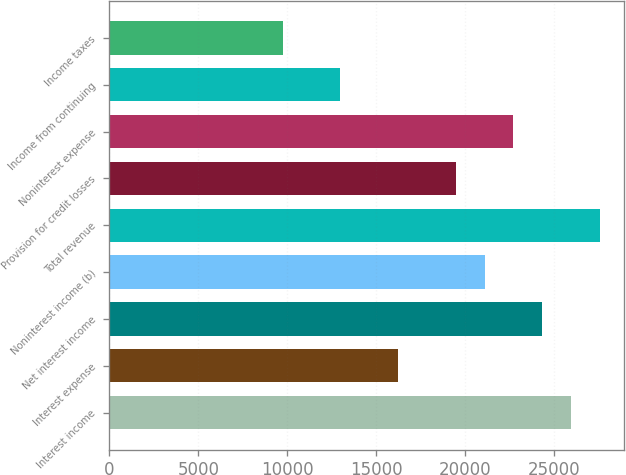Convert chart. <chart><loc_0><loc_0><loc_500><loc_500><bar_chart><fcel>Interest income<fcel>Interest expense<fcel>Net interest income<fcel>Noninterest income (b)<fcel>Total revenue<fcel>Provision for credit losses<fcel>Noninterest expense<fcel>Income from continuing<fcel>Income taxes<nl><fcel>25964.7<fcel>16228<fcel>24342<fcel>21096.4<fcel>27587.5<fcel>19473.6<fcel>22719.2<fcel>12982.4<fcel>9736.84<nl></chart> 